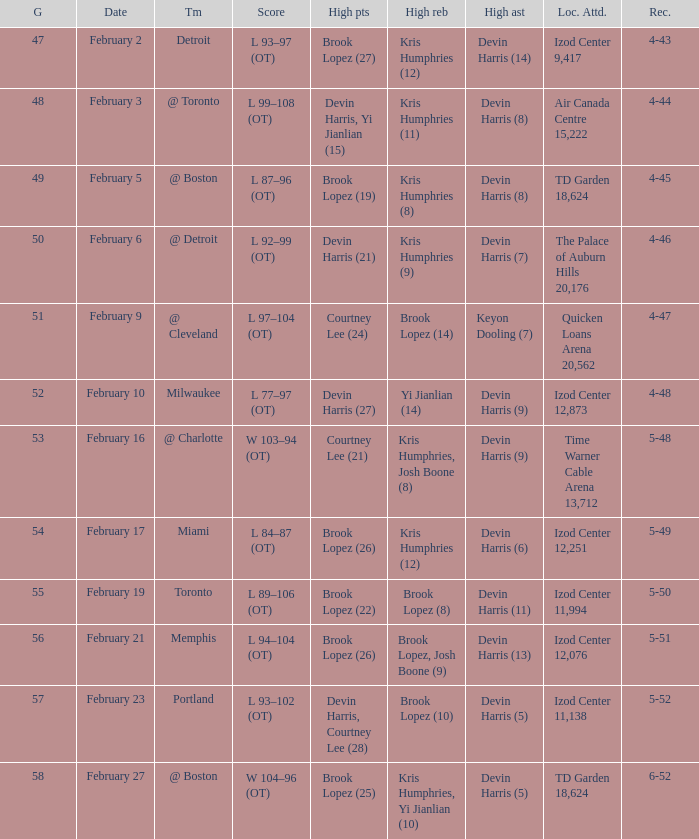What was the record in the game against Memphis? 5-51. 